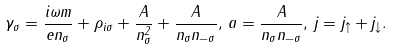Convert formula to latex. <formula><loc_0><loc_0><loc_500><loc_500>\gamma _ { \sigma } = \frac { i \omega m } { e n _ { \sigma } } + \rho _ { i \sigma } + \frac { A } { n _ { \sigma } ^ { 2 } } + \frac { A } { n _ { \sigma } n _ { - \sigma } } , \, a = \frac { A } { n _ { \sigma } n _ { - \sigma } } , \, j = j _ { \uparrow } + j _ { \downarrow } .</formula> 